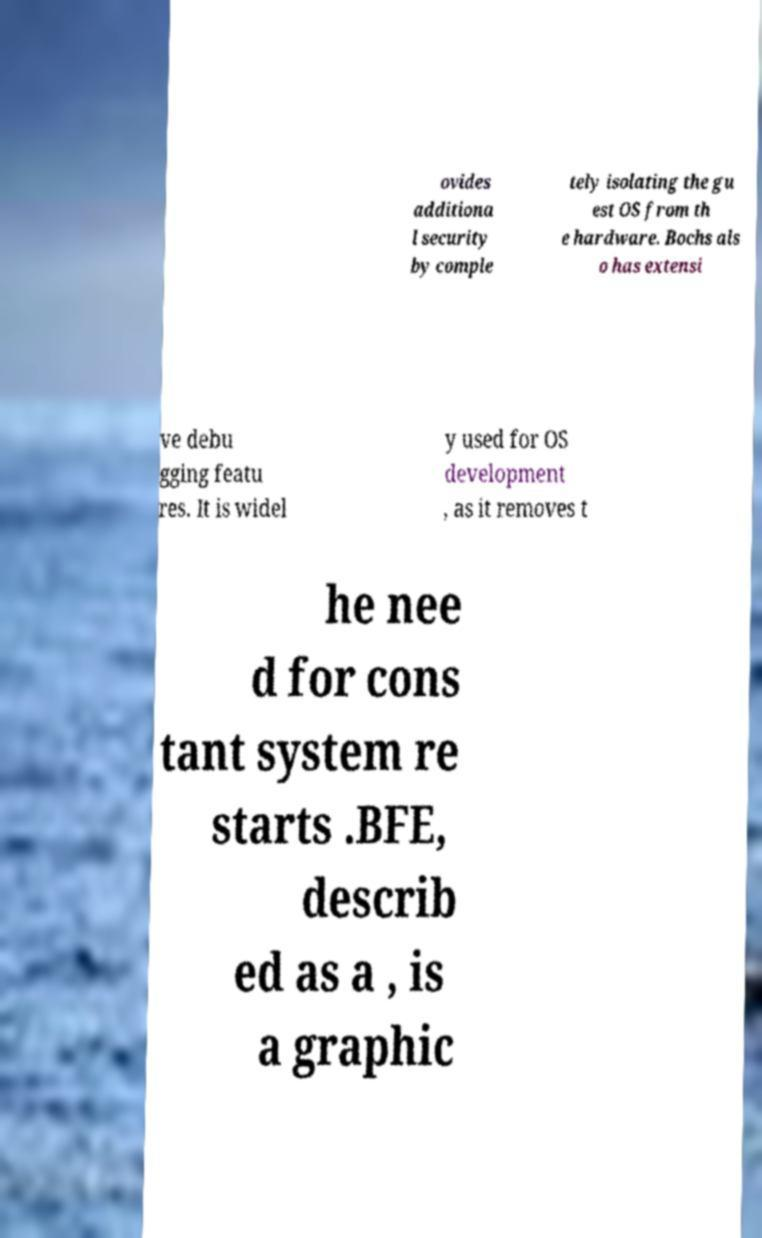Can you accurately transcribe the text from the provided image for me? ovides additiona l security by comple tely isolating the gu est OS from th e hardware. Bochs als o has extensi ve debu gging featu res. It is widel y used for OS development , as it removes t he nee d for cons tant system re starts .BFE, describ ed as a , is a graphic 